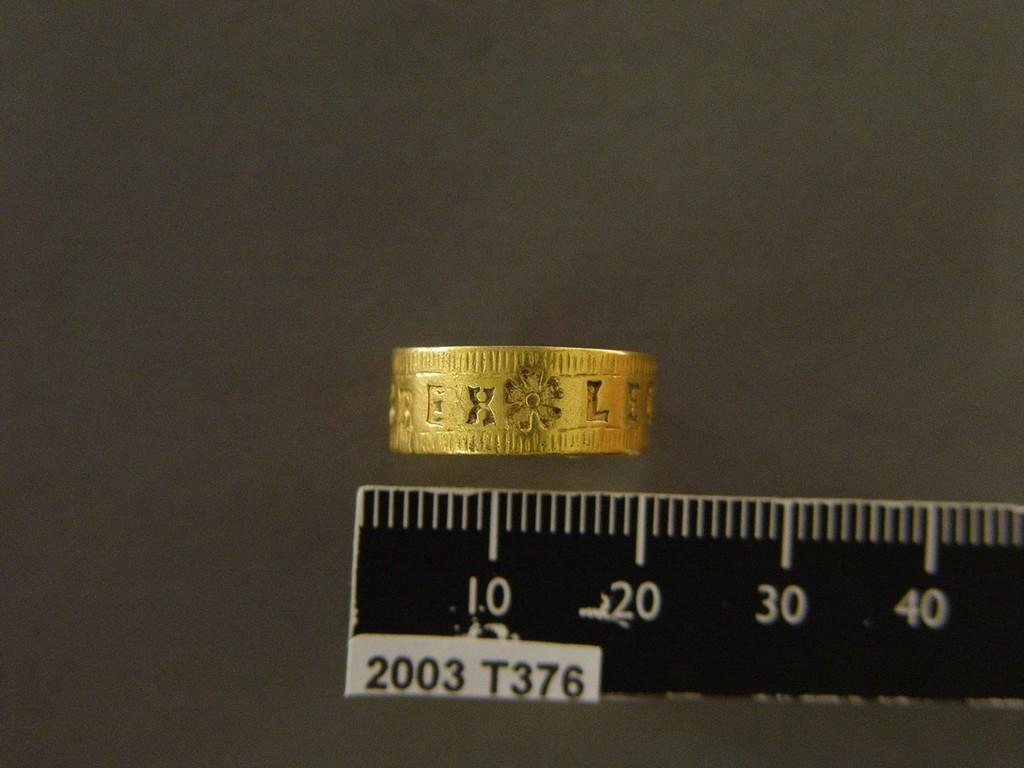<image>
Relay a brief, clear account of the picture shown. a ruler with the year 2003 at the bottom 